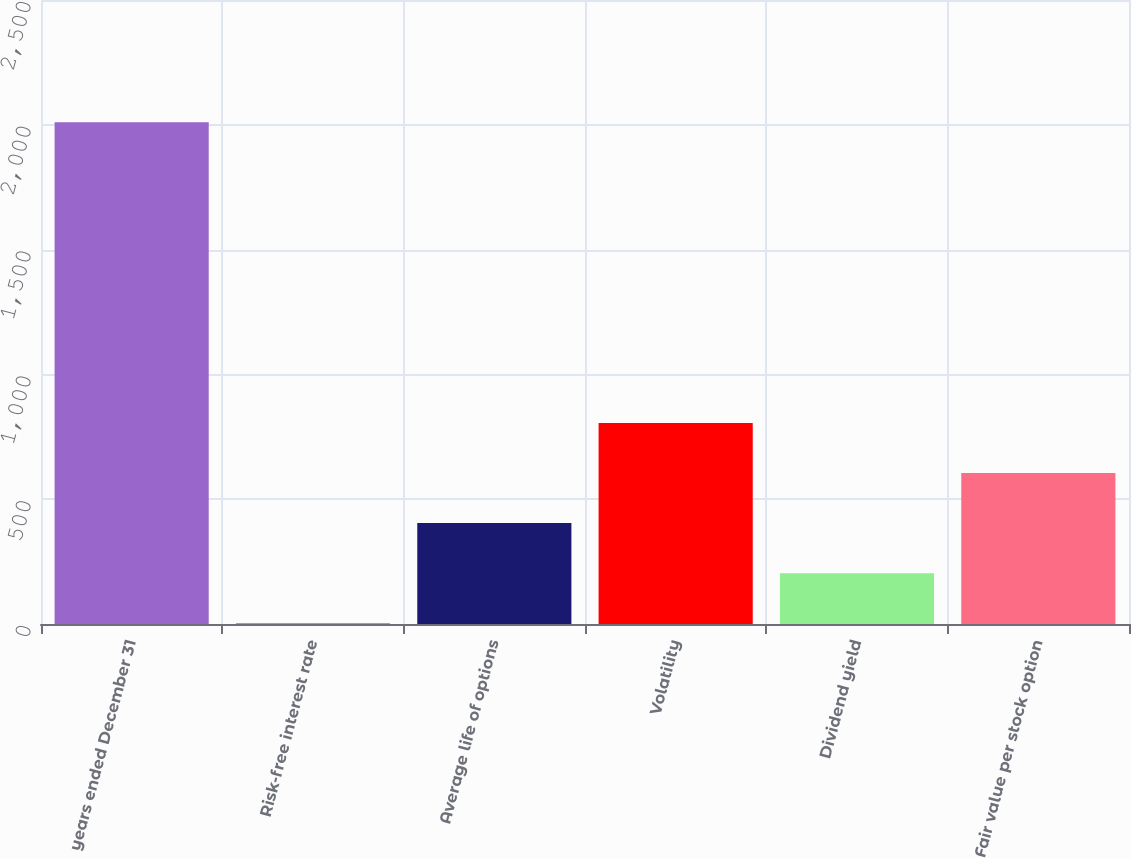<chart> <loc_0><loc_0><loc_500><loc_500><bar_chart><fcel>years ended December 31<fcel>Risk-free interest rate<fcel>Average life of options<fcel>Volatility<fcel>Dividend yield<fcel>Fair value per stock option<nl><fcel>2010<fcel>2.9<fcel>404.32<fcel>805.74<fcel>203.61<fcel>605.03<nl></chart> 